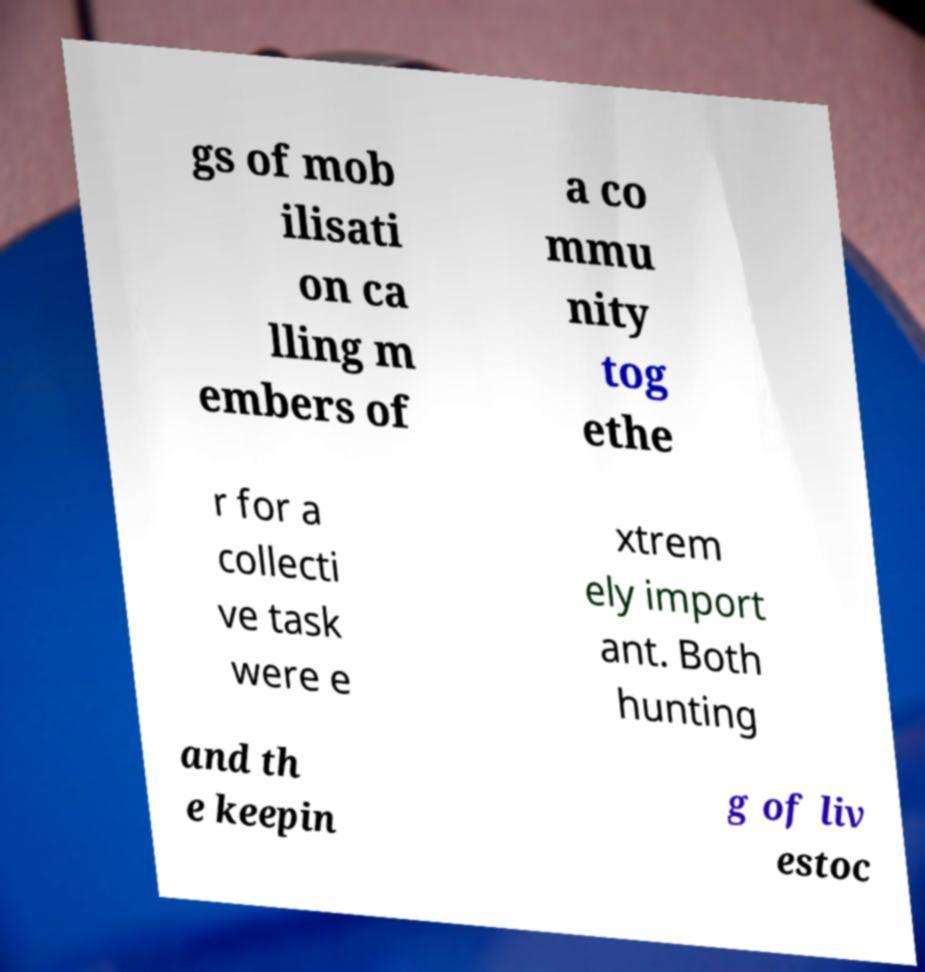For documentation purposes, I need the text within this image transcribed. Could you provide that? gs of mob ilisati on ca lling m embers of a co mmu nity tog ethe r for a collecti ve task were e xtrem ely import ant. Both hunting and th e keepin g of liv estoc 